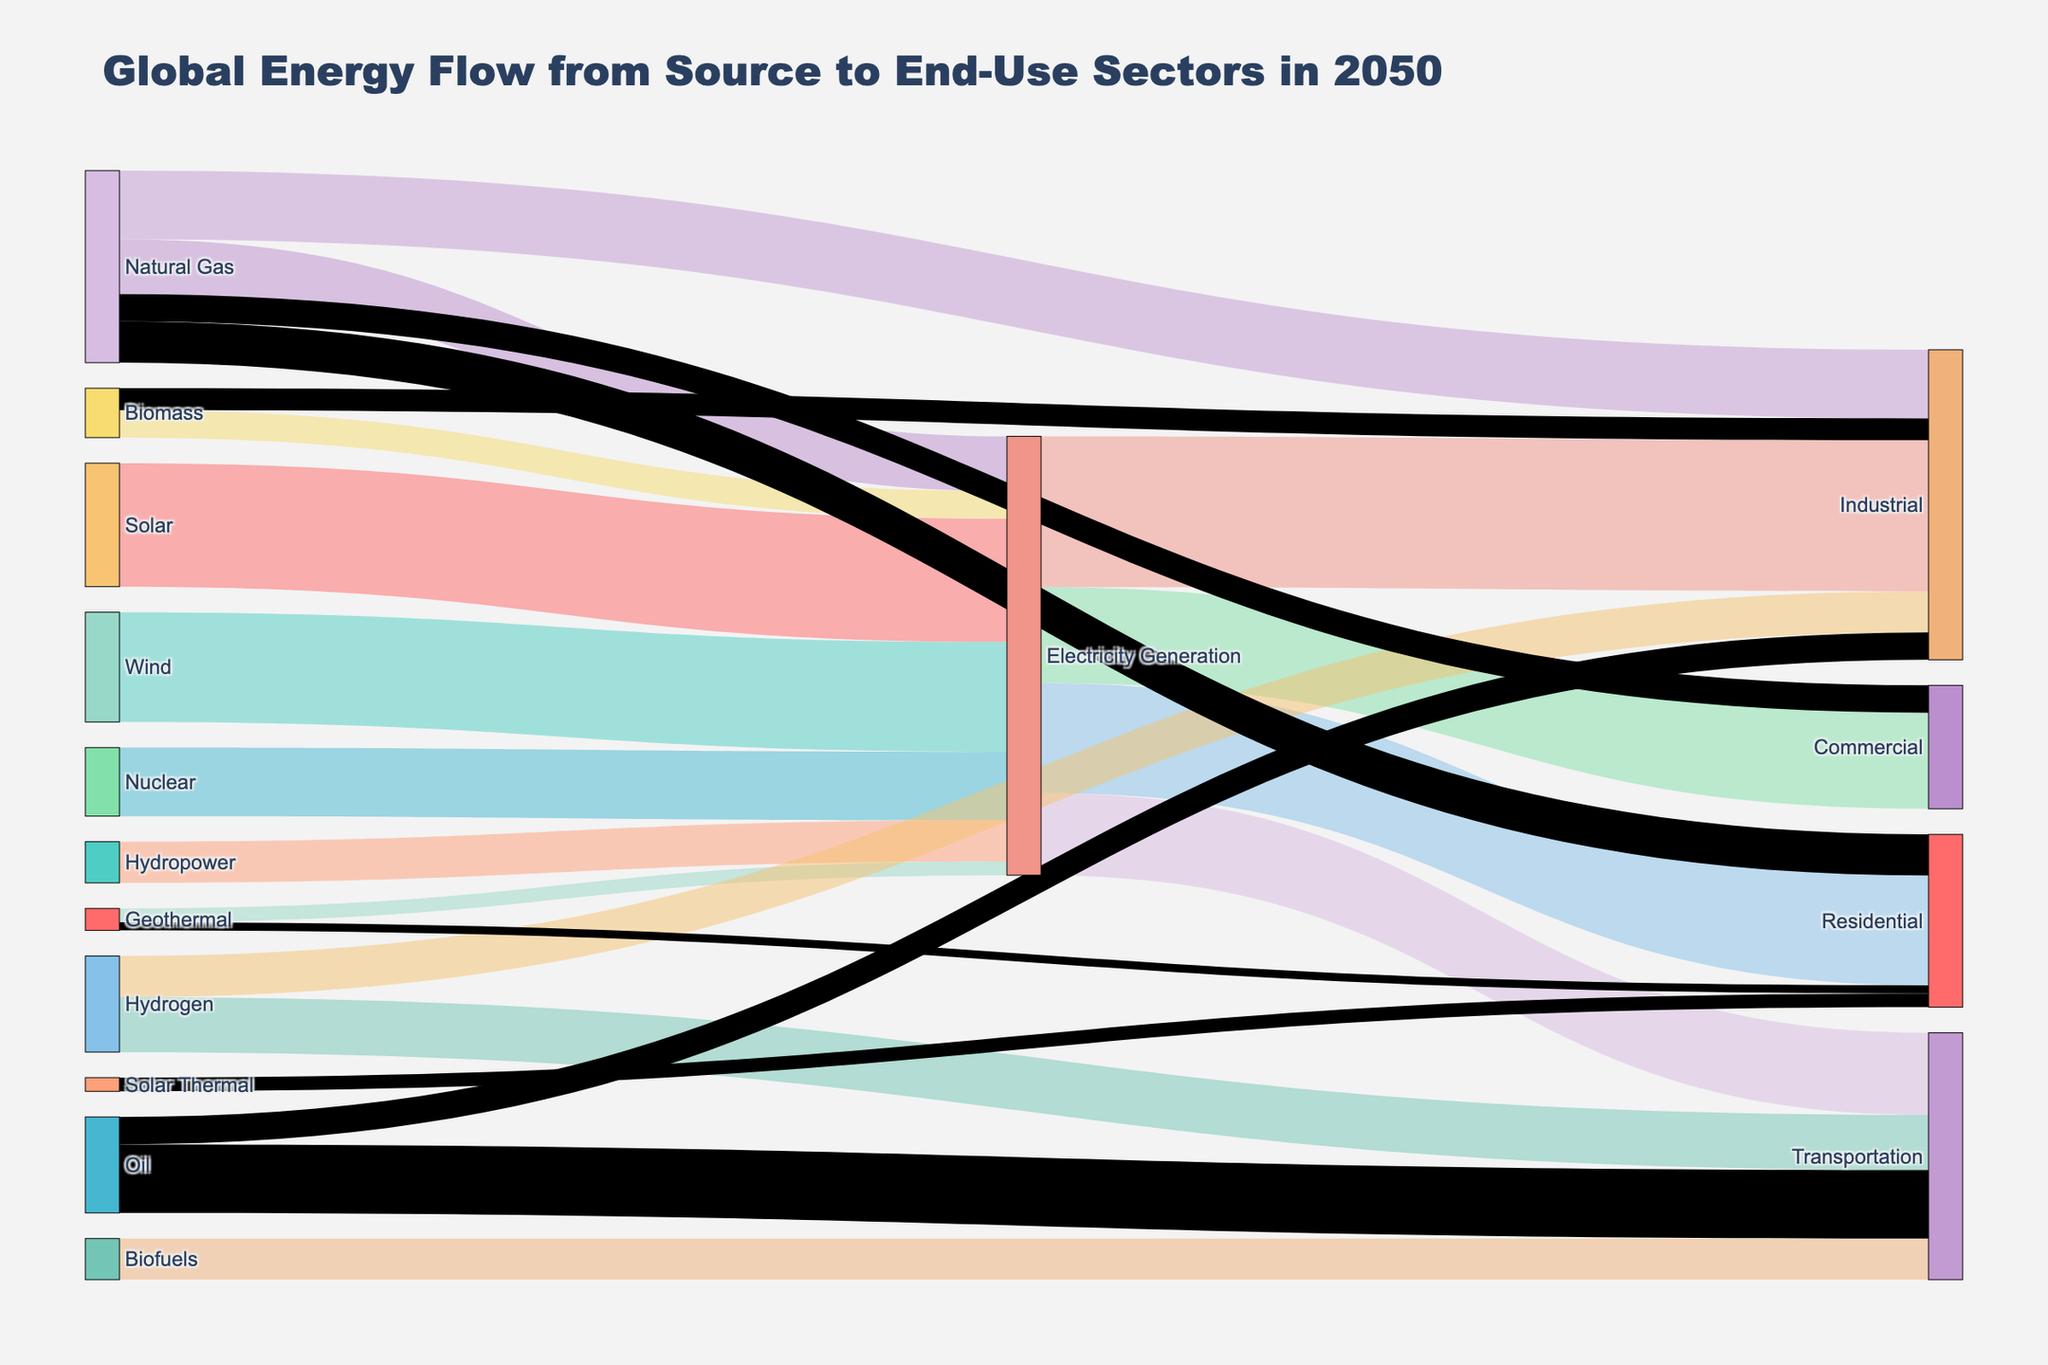How much energy is generated from Solar sources? Look at the link connecting "Solar" to "Electricity Generation". The value on this link indicates the energy generated from Solar sources.
Answer: 45 Which end-use sector gets the most energy from Electricity Generation? Check the links originating from "Electricity Generation" and compare their values. The highest value identifies the end-use sector receiving the most energy.
Answer: Industrial What is the total energy flow into the Transportation sector? Sum the values of all links that target "Transportation". These links are from "Electricity Generation", "Hydrogen", "Biofuels", and "Oil".
Answer: 30 (from Electricity) + 20 (from Hydrogen) + 15 (from Biofuels) + 25 (from Oil) = 90 Compare the energy flow from Natural Gas to Industrial and Residential sectors. Which one is higher? Identify and compare the values of links from "Natural Gas" that go to "Industrial" and "Residential".
Answer: Industrial has 25, Residential has 15. Industrial is higher What is the value of energy flow from Biomass to Industrial? Locate the link from "Biomass" to "Industrial" and check its value.
Answer: 8 How does the energy provided by Renewable sources (Solar, Wind, Nuclear, Hydropower, Geothermal, Biomass) compare to the energy provided by Natural Gas? Sum the values of links from each Renewable source and compare the total to the energy from Natural Gas.
Answer: Renewable: 45 (Solar) + 40 (Wind) + 25 (Nuclear) + 15 (Hydropower) + 5 (Geothermal) + 10 (Biomass) = 140. Natural Gas: 20+25+15+10 = 70. Renewable energy (140) is higher than Natural Gas (70) What is the proportion of energy from Biofuels within the Transportation sector? To find this, divide the energy from "Biofuels" to "Transportation" by the total energy flow into "Transportation".
Answer: Proportion = 15 / 90 = 1/6 Which source provides more energy, Solar or Wind? Compare the values of energy flows from "Solar" and "Wind" to "Electricity Generation".
Answer: Solar: 45, Wind: 40. Solar provides more Calculate the difference in energy flow between Oil and Hydrogen to the Industrial sector. Subtract the value of energy flow from "Oil" to "Industrial" from the value of energy flow from "Hydrogen" to "Industrial".
Answer: Difference = 15 (Hydrogen) - 10 (Oil) = 5 What percentage of total energy within the Industrial sector comes directly from Electricity Generation? Divide the energy from "Electricity Generation" to "Industrial" by the total sum of energy flows into "Industrial".
Answer: Percentage = (55 / (55+15+25+10+8)) * 100 = 50% 